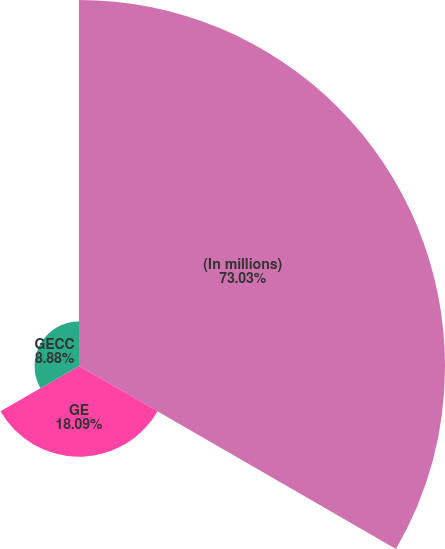Convert chart. <chart><loc_0><loc_0><loc_500><loc_500><pie_chart><fcel>(In millions)<fcel>GE<fcel>GECC<nl><fcel>73.02%<fcel>18.09%<fcel>8.88%<nl></chart> 